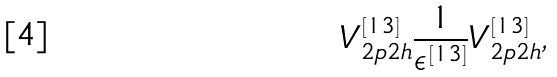Convert formula to latex. <formula><loc_0><loc_0><loc_500><loc_500>V _ { 2 p 2 h } ^ { [ 1 3 ] } \frac { 1 } { \epsilon ^ { [ 1 3 ] } } V _ { 2 p 2 h } ^ { [ 1 3 ] } ,</formula> 